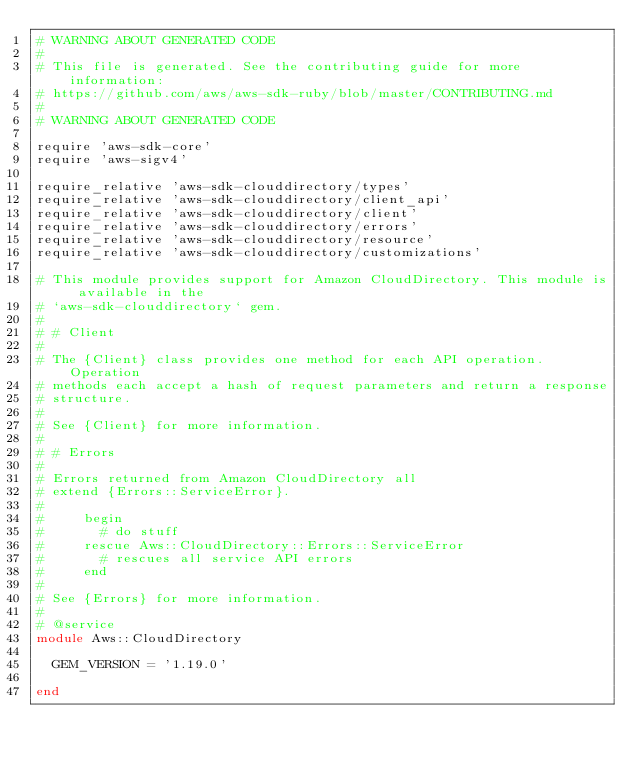Convert code to text. <code><loc_0><loc_0><loc_500><loc_500><_Ruby_># WARNING ABOUT GENERATED CODE
#
# This file is generated. See the contributing guide for more information:
# https://github.com/aws/aws-sdk-ruby/blob/master/CONTRIBUTING.md
#
# WARNING ABOUT GENERATED CODE

require 'aws-sdk-core'
require 'aws-sigv4'

require_relative 'aws-sdk-clouddirectory/types'
require_relative 'aws-sdk-clouddirectory/client_api'
require_relative 'aws-sdk-clouddirectory/client'
require_relative 'aws-sdk-clouddirectory/errors'
require_relative 'aws-sdk-clouddirectory/resource'
require_relative 'aws-sdk-clouddirectory/customizations'

# This module provides support for Amazon CloudDirectory. This module is available in the
# `aws-sdk-clouddirectory` gem.
#
# # Client
#
# The {Client} class provides one method for each API operation. Operation
# methods each accept a hash of request parameters and return a response
# structure.
#
# See {Client} for more information.
#
# # Errors
#
# Errors returned from Amazon CloudDirectory all
# extend {Errors::ServiceError}.
#
#     begin
#       # do stuff
#     rescue Aws::CloudDirectory::Errors::ServiceError
#       # rescues all service API errors
#     end
#
# See {Errors} for more information.
#
# @service
module Aws::CloudDirectory

  GEM_VERSION = '1.19.0'

end
</code> 